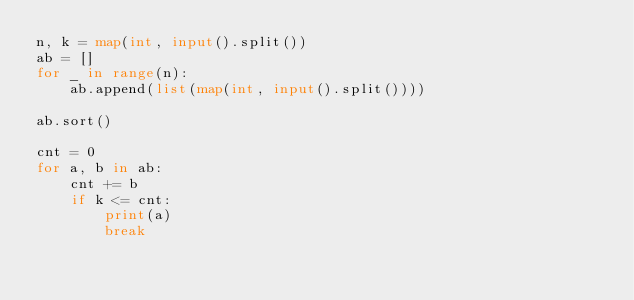<code> <loc_0><loc_0><loc_500><loc_500><_Python_>n, k = map(int, input().split())
ab = []
for _ in range(n):
    ab.append(list(map(int, input().split())))

ab.sort()

cnt = 0
for a, b in ab:
    cnt += b
    if k <= cnt:
        print(a)
        break
</code> 